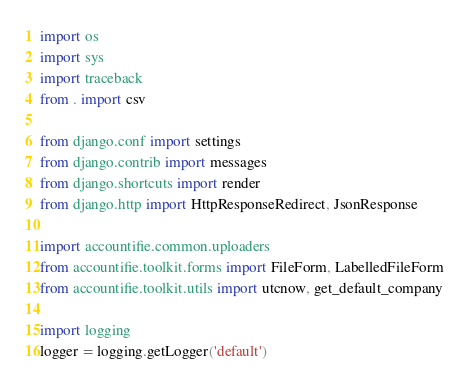Convert code to text. <code><loc_0><loc_0><loc_500><loc_500><_Python_>import os
import sys
import traceback
from . import csv

from django.conf import settings
from django.contrib import messages
from django.shortcuts import render
from django.http import HttpResponseRedirect, JsonResponse

import accountifie.common.uploaders
from accountifie.toolkit.forms import FileForm, LabelledFileForm
from accountifie.toolkit.utils import utcnow, get_default_company

import logging
logger = logging.getLogger('default')

</code> 